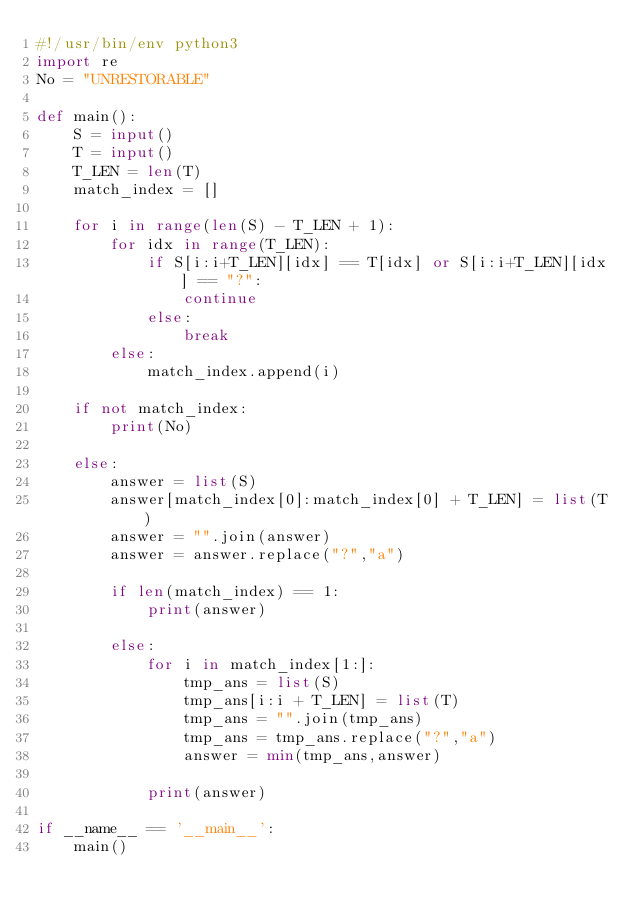Convert code to text. <code><loc_0><loc_0><loc_500><loc_500><_Python_>#!/usr/bin/env python3
import re
No = "UNRESTORABLE"

def main():
    S = input()
    T = input()
    T_LEN = len(T)
    match_index = []

    for i in range(len(S) - T_LEN + 1):
        for idx in range(T_LEN):
            if S[i:i+T_LEN][idx] == T[idx] or S[i:i+T_LEN][idx] == "?":
                continue
            else:
                break
        else:
            match_index.append(i)
    
    if not match_index:
        print(No)
    
    else:
        answer = list(S)
        answer[match_index[0]:match_index[0] + T_LEN] = list(T)
        answer = "".join(answer)
        answer = answer.replace("?","a")

        if len(match_index) == 1:
            print(answer)

        else:
            for i in match_index[1:]:
                tmp_ans = list(S)
                tmp_ans[i:i + T_LEN] = list(T)
                tmp_ans = "".join(tmp_ans)
                tmp_ans = tmp_ans.replace("?","a")
                answer = min(tmp_ans,answer)

            print(answer)

if __name__ == '__main__':
    main()</code> 